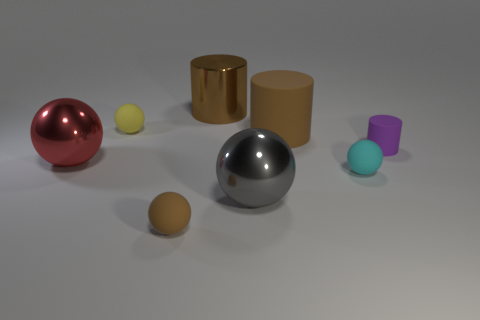Is the color of the large shiny cylinder the same as the big cylinder that is right of the gray shiny sphere?
Offer a very short reply. Yes. What number of small cyan cubes are there?
Offer a terse response. 0. Are there any large spheres that have the same color as the big matte object?
Offer a terse response. No. What color is the small matte sphere that is behind the matte cylinder in front of the large brown object in front of the large brown metal thing?
Offer a terse response. Yellow. Does the tiny yellow ball have the same material as the large ball in front of the cyan rubber sphere?
Provide a short and direct response. No. What material is the yellow object?
Provide a short and direct response. Rubber. There is another cylinder that is the same color as the large metal cylinder; what is its material?
Offer a very short reply. Rubber. How many other objects are there of the same material as the gray object?
Offer a very short reply. 2. There is a matte thing that is both behind the small purple cylinder and on the right side of the tiny brown sphere; what shape is it?
Provide a short and direct response. Cylinder. What color is the big cylinder that is the same material as the small cyan sphere?
Your answer should be compact. Brown. 